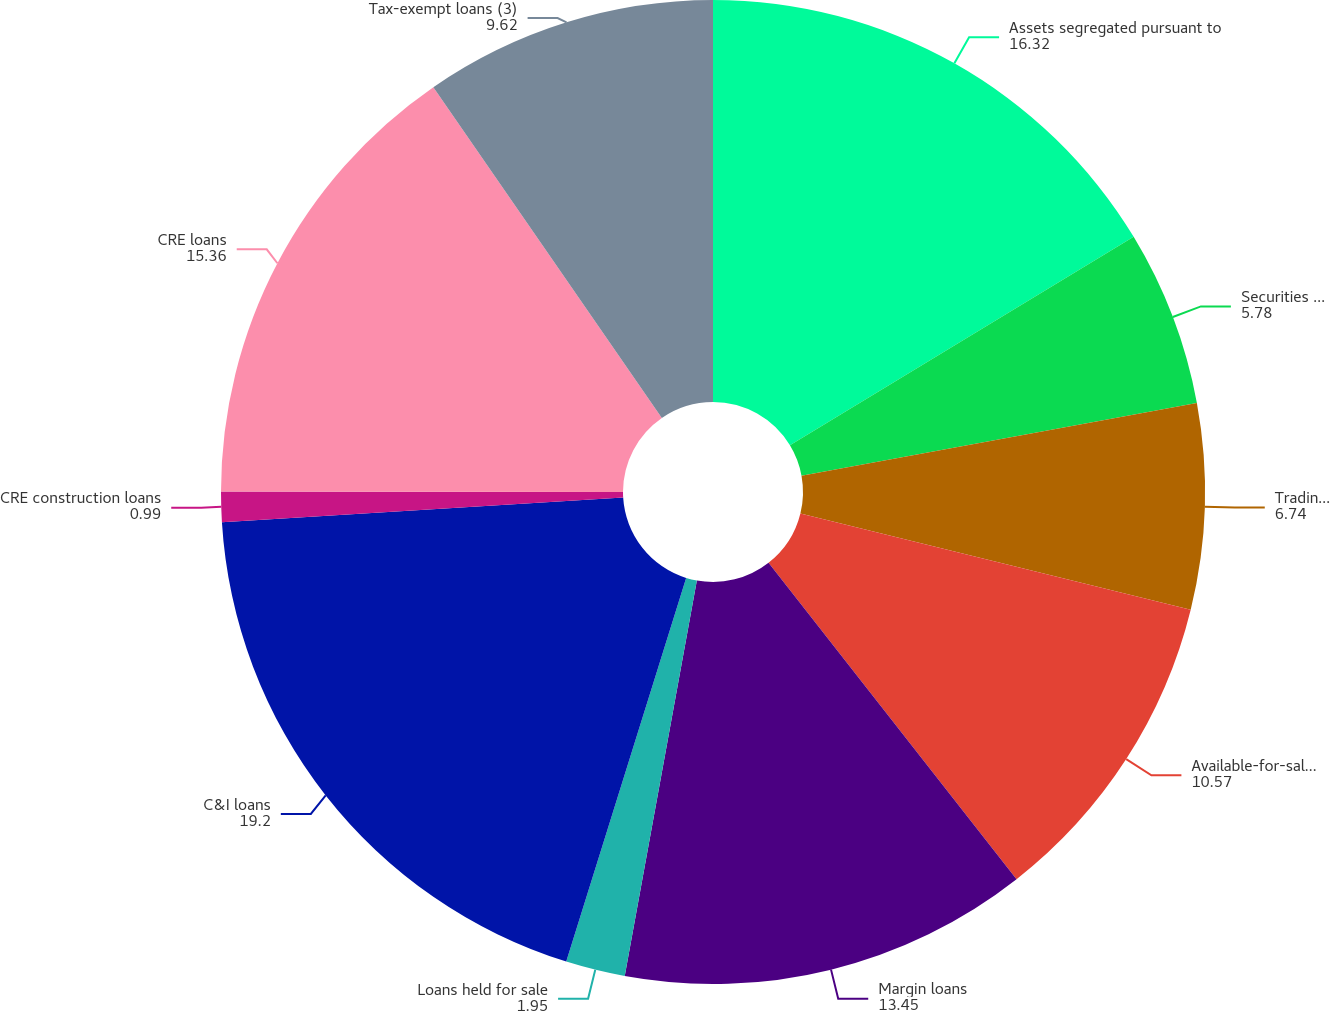<chart> <loc_0><loc_0><loc_500><loc_500><pie_chart><fcel>Assets segregated pursuant to<fcel>Securities loaned<fcel>Trading instruments (1)<fcel>Available-for-sale securities<fcel>Margin loans<fcel>Loans held for sale<fcel>C&I loans<fcel>CRE construction loans<fcel>CRE loans<fcel>Tax-exempt loans (3)<nl><fcel>16.32%<fcel>5.78%<fcel>6.74%<fcel>10.57%<fcel>13.45%<fcel>1.95%<fcel>19.2%<fcel>0.99%<fcel>15.36%<fcel>9.62%<nl></chart> 